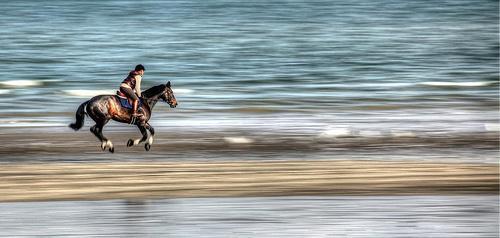How many horses are visible?
Give a very brief answer. 1. 